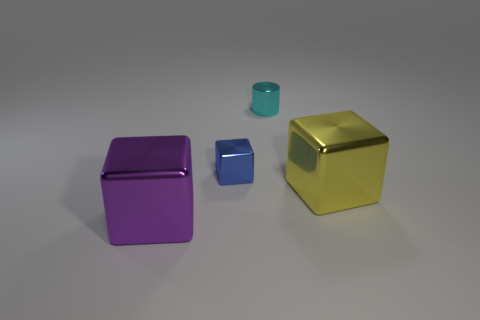Add 3 shiny cylinders. How many objects exist? 7 Subtract all blocks. How many objects are left? 1 Add 2 cyan cylinders. How many cyan cylinders are left? 3 Add 2 small yellow matte cylinders. How many small yellow matte cylinders exist? 2 Subtract 1 purple blocks. How many objects are left? 3 Subtract all tiny cyan things. Subtract all blue metal things. How many objects are left? 2 